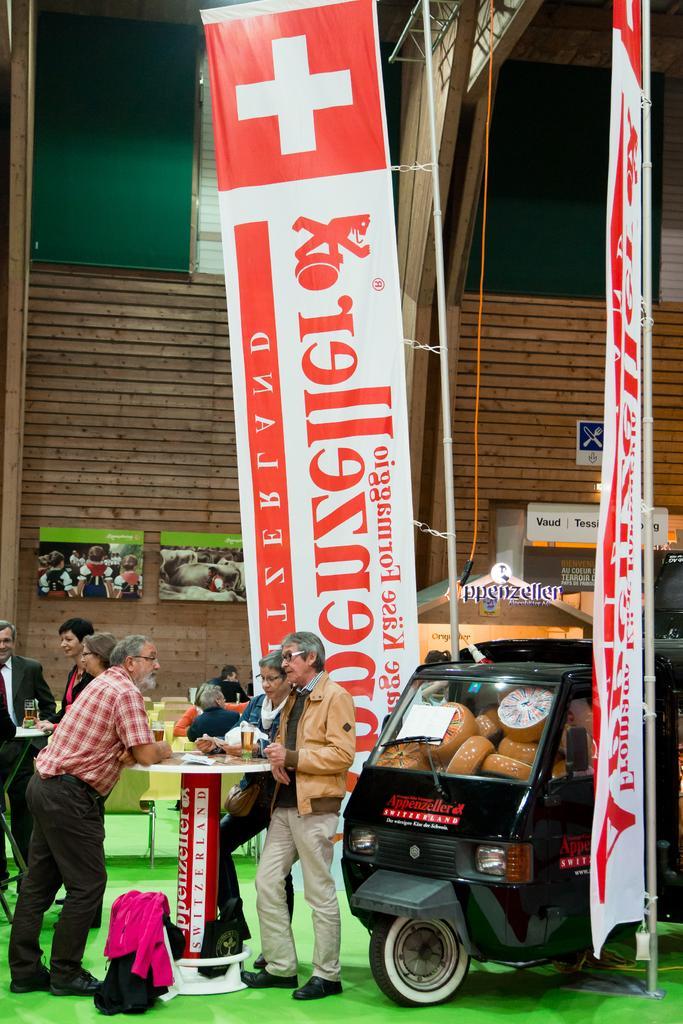Describe this image in one or two sentences. In this image at the bottom left there is a man, he wears a shirt, trouser, shoes, in front of him there is a man, he wears a jacket, trouser, shoes. In the middle of them there is a table on that there are glasses. On the right there is a vehicle. In the background there are posters, people, screens, wall, lights, roof. 